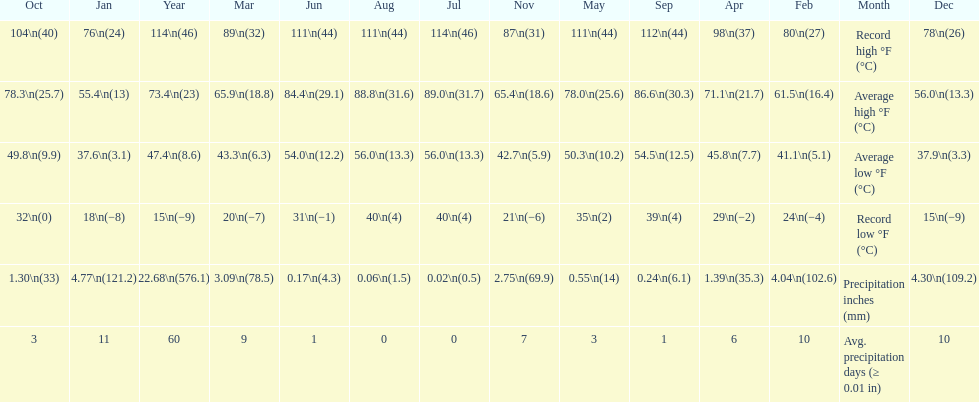Write the full table. {'header': ['Oct', 'Jan', 'Year', 'Mar', 'Jun', 'Aug', 'Jul', 'Nov', 'May', 'Sep', 'Apr', 'Feb', 'Month', 'Dec'], 'rows': [['104\\n(40)', '76\\n(24)', '114\\n(46)', '89\\n(32)', '111\\n(44)', '111\\n(44)', '114\\n(46)', '87\\n(31)', '111\\n(44)', '112\\n(44)', '98\\n(37)', '80\\n(27)', 'Record high °F (°C)', '78\\n(26)'], ['78.3\\n(25.7)', '55.4\\n(13)', '73.4\\n(23)', '65.9\\n(18.8)', '84.4\\n(29.1)', '88.8\\n(31.6)', '89.0\\n(31.7)', '65.4\\n(18.6)', '78.0\\n(25.6)', '86.6\\n(30.3)', '71.1\\n(21.7)', '61.5\\n(16.4)', 'Average high °F (°C)', '56.0\\n(13.3)'], ['49.8\\n(9.9)', '37.6\\n(3.1)', '47.4\\n(8.6)', '43.3\\n(6.3)', '54.0\\n(12.2)', '56.0\\n(13.3)', '56.0\\n(13.3)', '42.7\\n(5.9)', '50.3\\n(10.2)', '54.5\\n(12.5)', '45.8\\n(7.7)', '41.1\\n(5.1)', 'Average low °F (°C)', '37.9\\n(3.3)'], ['32\\n(0)', '18\\n(−8)', '15\\n(−9)', '20\\n(−7)', '31\\n(−1)', '40\\n(4)', '40\\n(4)', '21\\n(−6)', '35\\n(2)', '39\\n(4)', '29\\n(−2)', '24\\n(−4)', 'Record low °F (°C)', '15\\n(−9)'], ['1.30\\n(33)', '4.77\\n(121.2)', '22.68\\n(576.1)', '3.09\\n(78.5)', '0.17\\n(4.3)', '0.06\\n(1.5)', '0.02\\n(0.5)', '2.75\\n(69.9)', '0.55\\n(14)', '0.24\\n(6.1)', '1.39\\n(35.3)', '4.04\\n(102.6)', 'Precipitation inches (mm)', '4.30\\n(109.2)'], ['3', '11', '60', '9', '1', '0', '0', '7', '3', '1', '6', '10', 'Avg. precipitation days (≥ 0.01 in)', '10']]} How many months how a record low below 25 degrees? 6. 